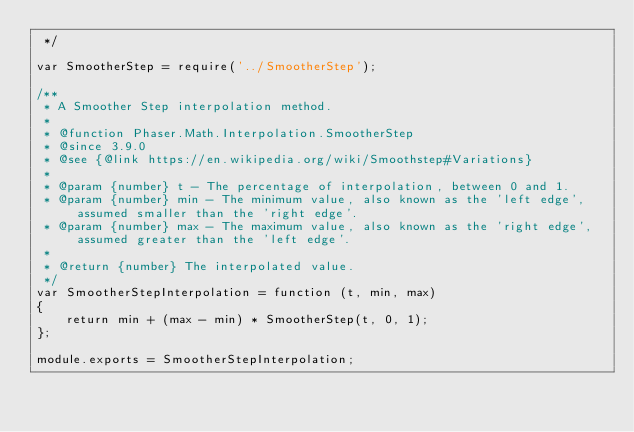Convert code to text. <code><loc_0><loc_0><loc_500><loc_500><_JavaScript_> */

var SmootherStep = require('../SmootherStep');

/**
 * A Smoother Step interpolation method.
 *
 * @function Phaser.Math.Interpolation.SmootherStep
 * @since 3.9.0
 * @see {@link https://en.wikipedia.org/wiki/Smoothstep#Variations}
 *
 * @param {number} t - The percentage of interpolation, between 0 and 1.
 * @param {number} min - The minimum value, also known as the 'left edge', assumed smaller than the 'right edge'.
 * @param {number} max - The maximum value, also known as the 'right edge', assumed greater than the 'left edge'.
 *
 * @return {number} The interpolated value.
 */
var SmootherStepInterpolation = function (t, min, max)
{
    return min + (max - min) * SmootherStep(t, 0, 1);
};

module.exports = SmootherStepInterpolation;
</code> 